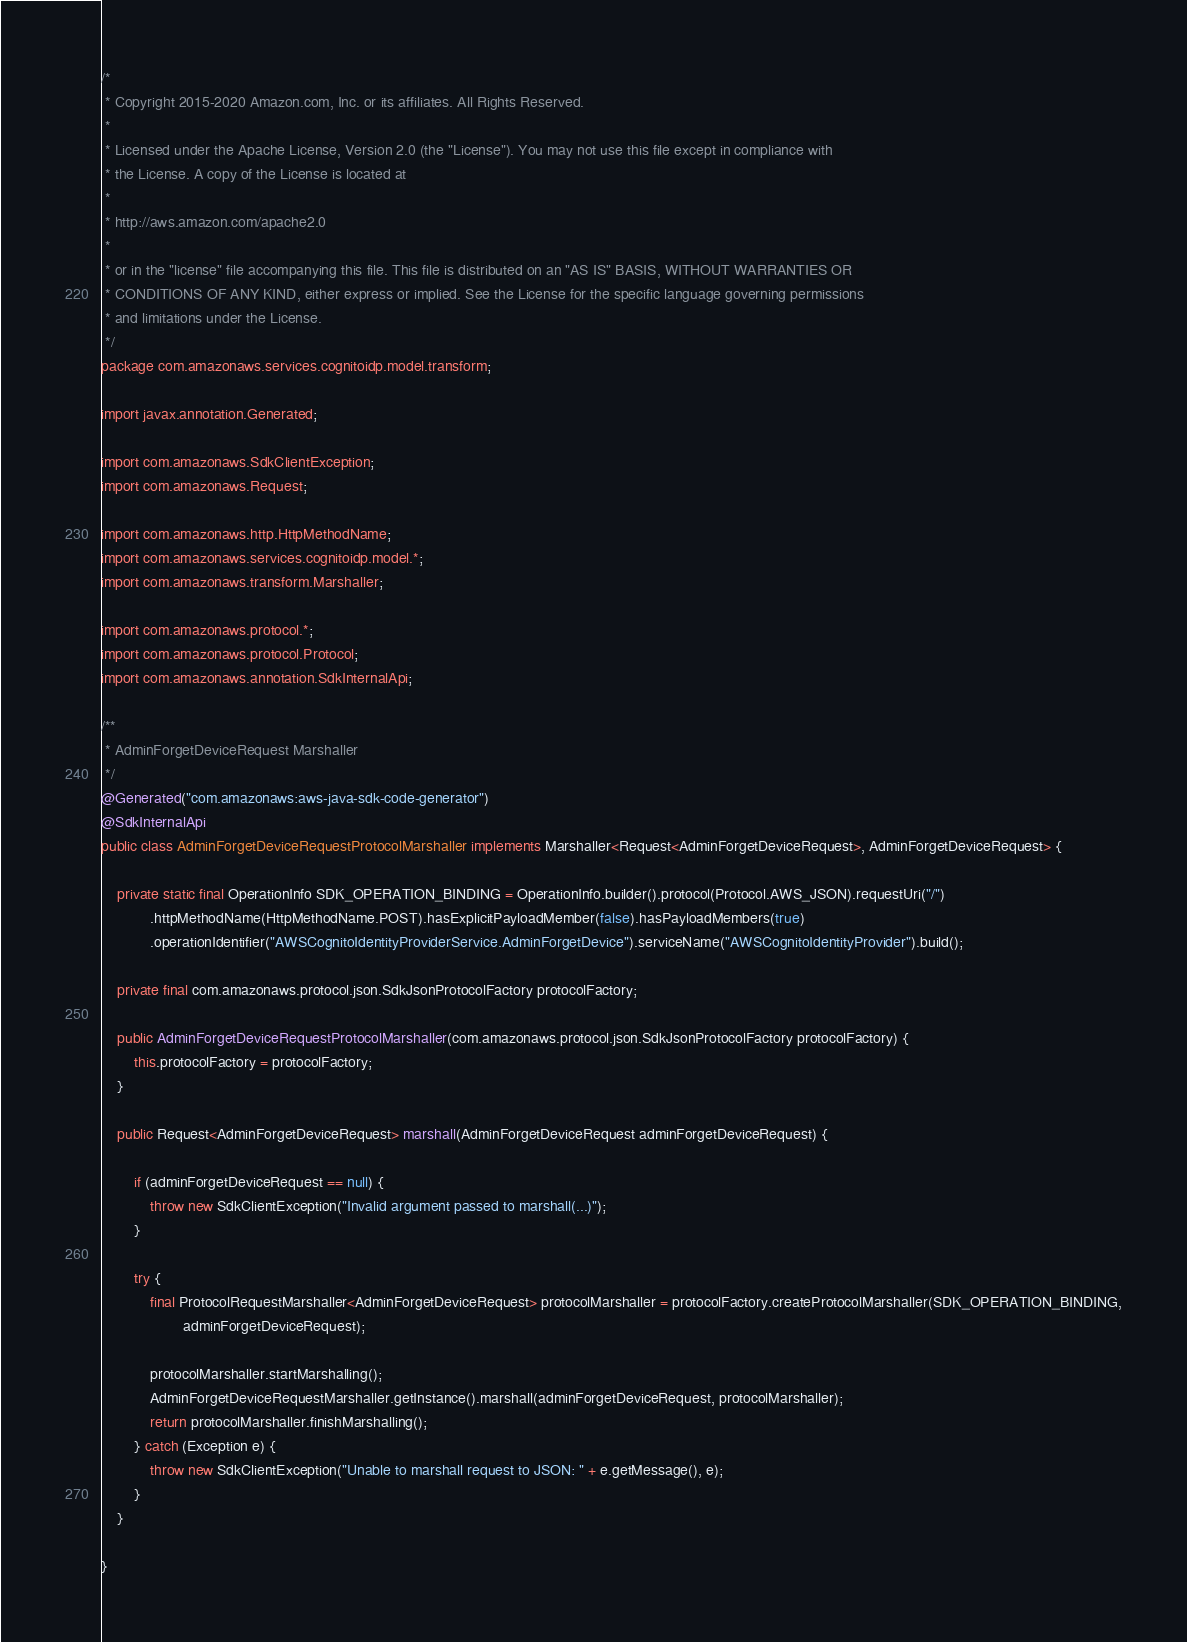<code> <loc_0><loc_0><loc_500><loc_500><_Java_>/*
 * Copyright 2015-2020 Amazon.com, Inc. or its affiliates. All Rights Reserved.
 * 
 * Licensed under the Apache License, Version 2.0 (the "License"). You may not use this file except in compliance with
 * the License. A copy of the License is located at
 * 
 * http://aws.amazon.com/apache2.0
 * 
 * or in the "license" file accompanying this file. This file is distributed on an "AS IS" BASIS, WITHOUT WARRANTIES OR
 * CONDITIONS OF ANY KIND, either express or implied. See the License for the specific language governing permissions
 * and limitations under the License.
 */
package com.amazonaws.services.cognitoidp.model.transform;

import javax.annotation.Generated;

import com.amazonaws.SdkClientException;
import com.amazonaws.Request;

import com.amazonaws.http.HttpMethodName;
import com.amazonaws.services.cognitoidp.model.*;
import com.amazonaws.transform.Marshaller;

import com.amazonaws.protocol.*;
import com.amazonaws.protocol.Protocol;
import com.amazonaws.annotation.SdkInternalApi;

/**
 * AdminForgetDeviceRequest Marshaller
 */
@Generated("com.amazonaws:aws-java-sdk-code-generator")
@SdkInternalApi
public class AdminForgetDeviceRequestProtocolMarshaller implements Marshaller<Request<AdminForgetDeviceRequest>, AdminForgetDeviceRequest> {

    private static final OperationInfo SDK_OPERATION_BINDING = OperationInfo.builder().protocol(Protocol.AWS_JSON).requestUri("/")
            .httpMethodName(HttpMethodName.POST).hasExplicitPayloadMember(false).hasPayloadMembers(true)
            .operationIdentifier("AWSCognitoIdentityProviderService.AdminForgetDevice").serviceName("AWSCognitoIdentityProvider").build();

    private final com.amazonaws.protocol.json.SdkJsonProtocolFactory protocolFactory;

    public AdminForgetDeviceRequestProtocolMarshaller(com.amazonaws.protocol.json.SdkJsonProtocolFactory protocolFactory) {
        this.protocolFactory = protocolFactory;
    }

    public Request<AdminForgetDeviceRequest> marshall(AdminForgetDeviceRequest adminForgetDeviceRequest) {

        if (adminForgetDeviceRequest == null) {
            throw new SdkClientException("Invalid argument passed to marshall(...)");
        }

        try {
            final ProtocolRequestMarshaller<AdminForgetDeviceRequest> protocolMarshaller = protocolFactory.createProtocolMarshaller(SDK_OPERATION_BINDING,
                    adminForgetDeviceRequest);

            protocolMarshaller.startMarshalling();
            AdminForgetDeviceRequestMarshaller.getInstance().marshall(adminForgetDeviceRequest, protocolMarshaller);
            return protocolMarshaller.finishMarshalling();
        } catch (Exception e) {
            throw new SdkClientException("Unable to marshall request to JSON: " + e.getMessage(), e);
        }
    }

}
</code> 